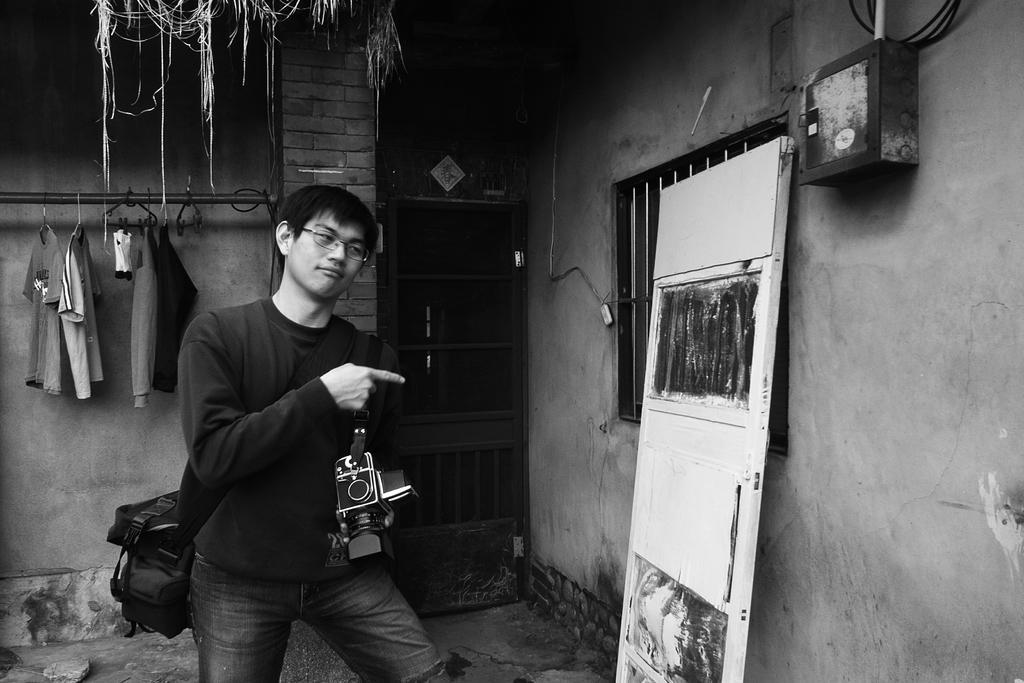Please provide a concise description of this image. In the middle of the image we can see a man, he wore a bag and he is holding a camera, in front of him we can see a door, few metal rods and a box on the wall, behind him we can find few clothes and it is a black and white photography. 